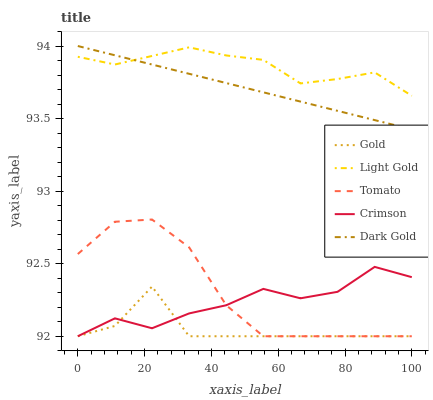Does Gold have the minimum area under the curve?
Answer yes or no. Yes. Does Light Gold have the maximum area under the curve?
Answer yes or no. Yes. Does Crimson have the minimum area under the curve?
Answer yes or no. No. Does Crimson have the maximum area under the curve?
Answer yes or no. No. Is Dark Gold the smoothest?
Answer yes or no. Yes. Is Gold the roughest?
Answer yes or no. Yes. Is Crimson the smoothest?
Answer yes or no. No. Is Crimson the roughest?
Answer yes or no. No. Does Light Gold have the lowest value?
Answer yes or no. No. Does Crimson have the highest value?
Answer yes or no. No. Is Crimson less than Dark Gold?
Answer yes or no. Yes. Is Dark Gold greater than Gold?
Answer yes or no. Yes. Does Crimson intersect Dark Gold?
Answer yes or no. No. 